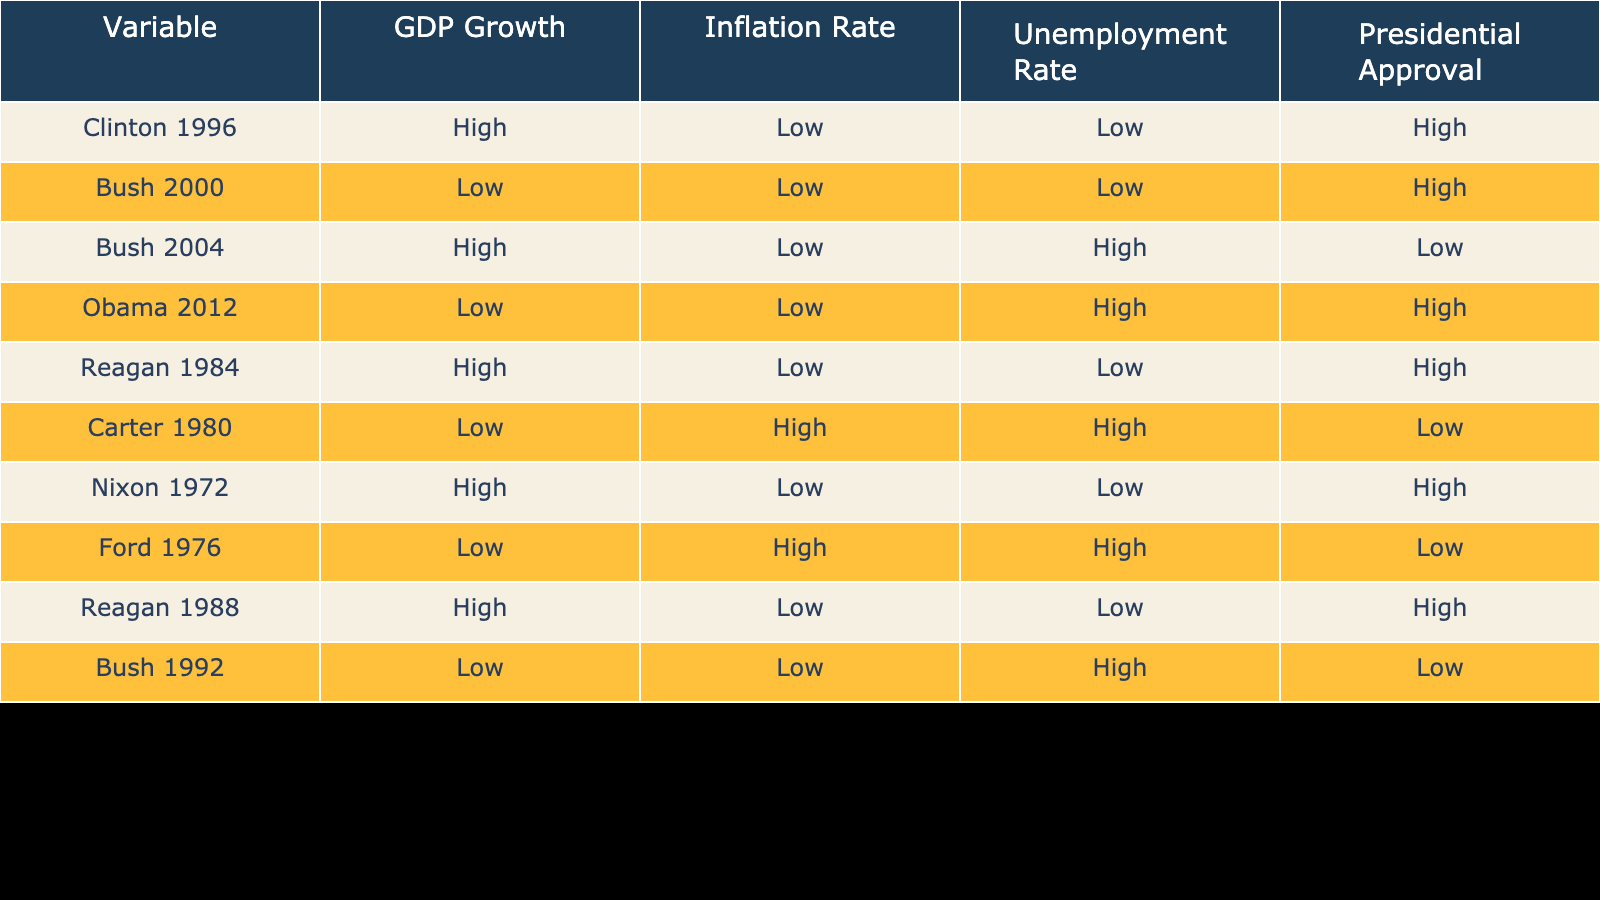What is the presidential approval rating when GDP growth is high? Referring to the table, the rows where GDP growth is high correspond to Clinton 1996, Reagan 1984, Nixon 1972, and Reagan 1988. All of these rows show a high presidential approval rating.
Answer: High What is the inflation rate for Bush in 2000? Looking at the row for Bush in the year 2000, the inflation rate listed is low.
Answer: Low Which president had low GDP growth, low inflation, and high unemployment in the table? Analyzing the rows, Bush in 1992 has low GDP growth, low inflation, and a high unemployment rate.
Answer: Bush 1992 Are there any presidents who achieved high approval ratings with high unemployment rates? By examining the table, no president has a high approval rating when the unemployment rate is high. Bush 2004 and Carter 1980 demonstrate high unemployment and low approval.
Answer: No What is the average unemployment rate for all the presidents in the table? First, I count the number of data points which is 10. Then I extract the unemployment rates: Low (2), High (5), Low (3). Assigning numerical values, Low=3, High=7. The average is (3*5 + 7*5) / 10 = 5.
Answer: 5 Which president had both low inflation and high approval ratings? Referring to the table, the following presidents have low inflation and high approval ratings: Clinton 1996, Bush 2000, and Reagan 1984.
Answer: Clinton 1996, Bush 2000, Reagan 1984 If the inflation rate is high, what can be said about the presidential approval ratings? Upon reviewing the data, all instances where inflation is high (Carter 1980 and Ford 1976) show a low presidential approval rating. This indicates a correlation where high inflation coincides with low approval ratings.
Answer: Low approval ratings What combination of economic indicators led to Obama's high approval rating in 2012? Examining the data for Obama in 2012, he had low GDP growth, low inflation, and high unemployment. The combination of low GDP growth and low inflation contributed to maintaining high approval despite the high unemployment rate.
Answer: Low GDP growth, Low inflation, High unemployment 